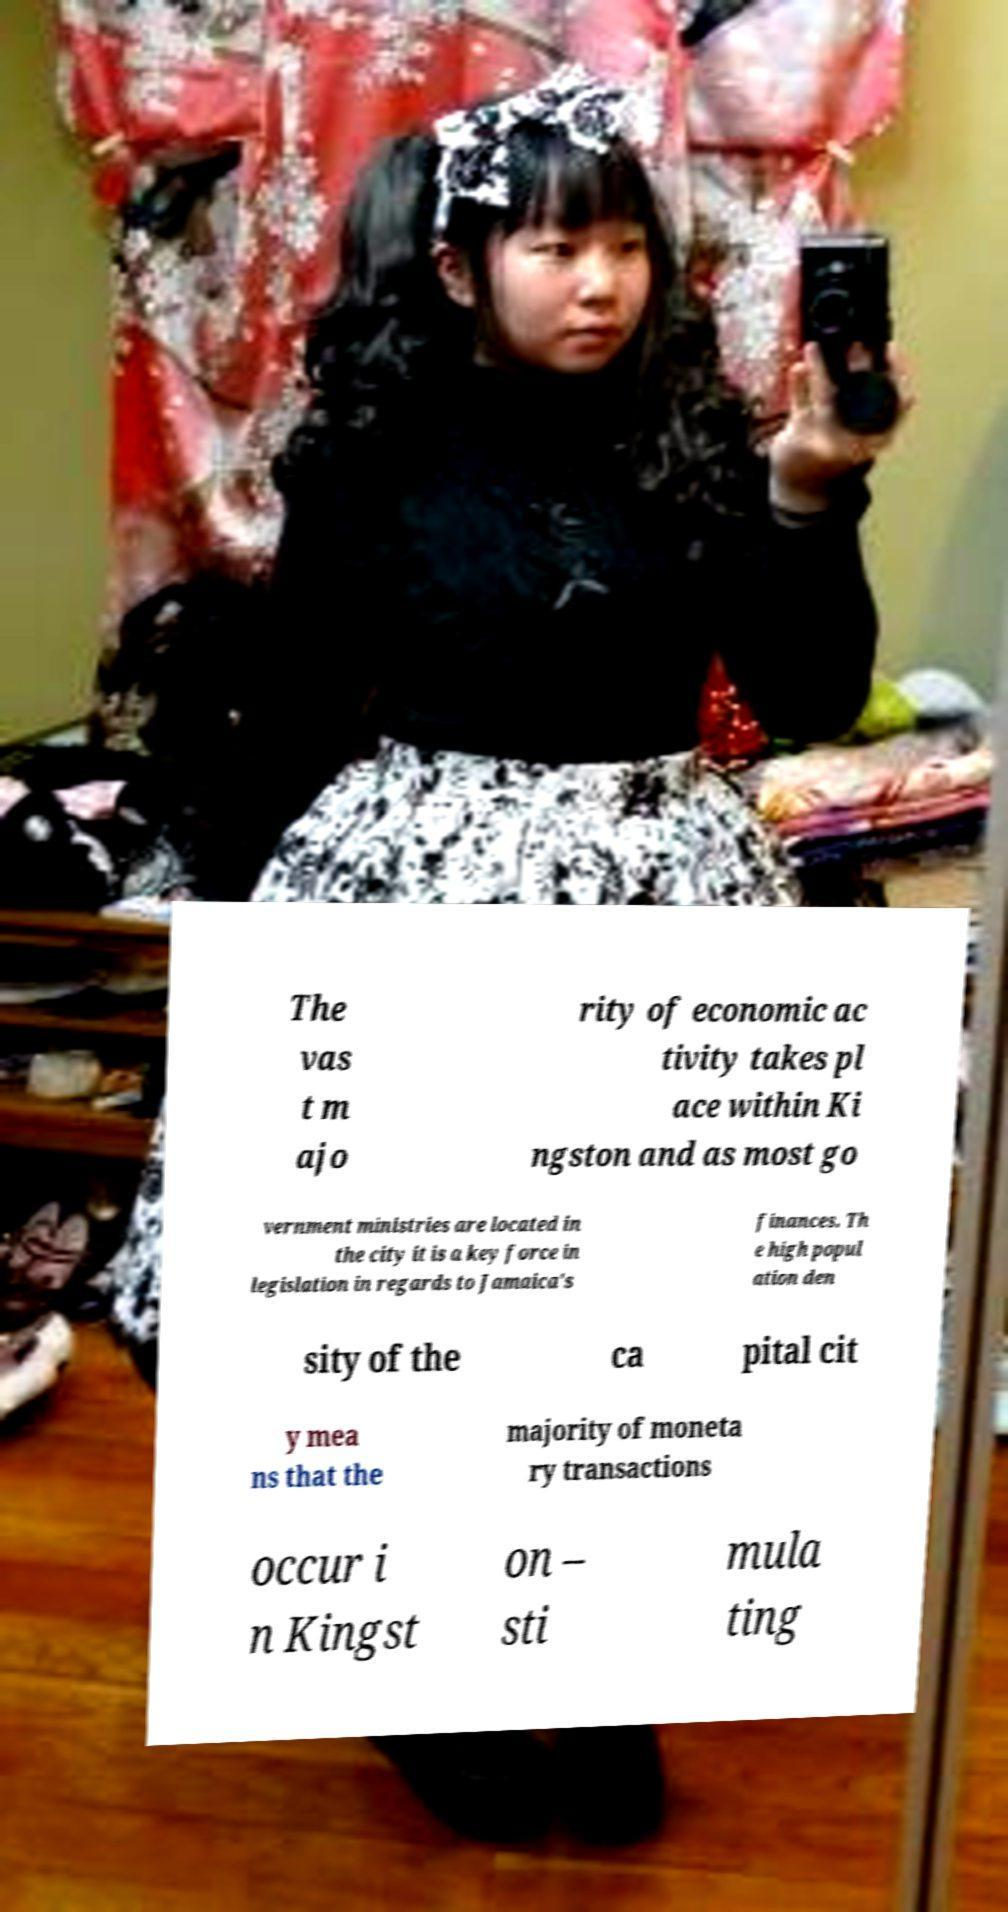Please identify and transcribe the text found in this image. The vas t m ajo rity of economic ac tivity takes pl ace within Ki ngston and as most go vernment ministries are located in the city it is a key force in legislation in regards to Jamaica's finances. Th e high popul ation den sity of the ca pital cit y mea ns that the majority of moneta ry transactions occur i n Kingst on – sti mula ting 